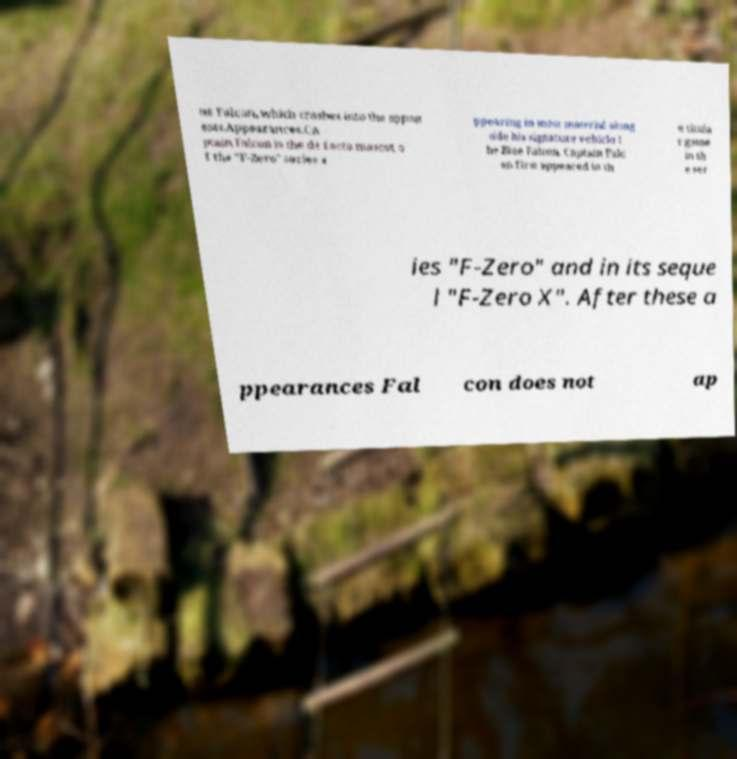Can you read and provide the text displayed in the image?This photo seems to have some interesting text. Can you extract and type it out for me? ue Falcon, which crashes into the oppon ents.Appearances.Ca ptain Falcon is the de facto mascot o f the "F-Zero" series a ppearing in most material along side his signature vehicle t he Blue Falcon. Captain Falc on first appeared in th e titula r game in th e ser ies "F-Zero" and in its seque l "F-Zero X". After these a ppearances Fal con does not ap 